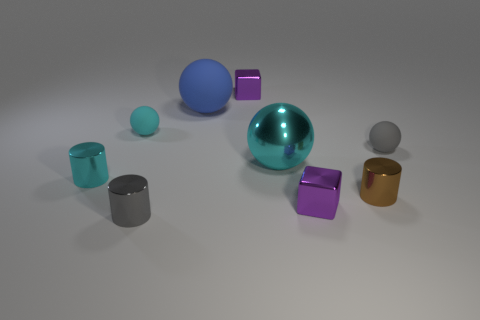Subtract all metal balls. How many balls are left? 3 Subtract all cyan balls. How many balls are left? 2 Add 1 tiny cyan balls. How many objects exist? 10 Subtract all spheres. How many objects are left? 5 Subtract all green cylinders. How many cyan balls are left? 2 Add 5 purple metallic objects. How many purple metallic objects exist? 7 Subtract 0 brown balls. How many objects are left? 9 Subtract 3 cylinders. How many cylinders are left? 0 Subtract all green cubes. Subtract all green balls. How many cubes are left? 2 Subtract all blue metal cubes. Subtract all gray matte balls. How many objects are left? 8 